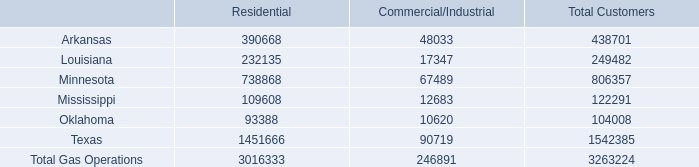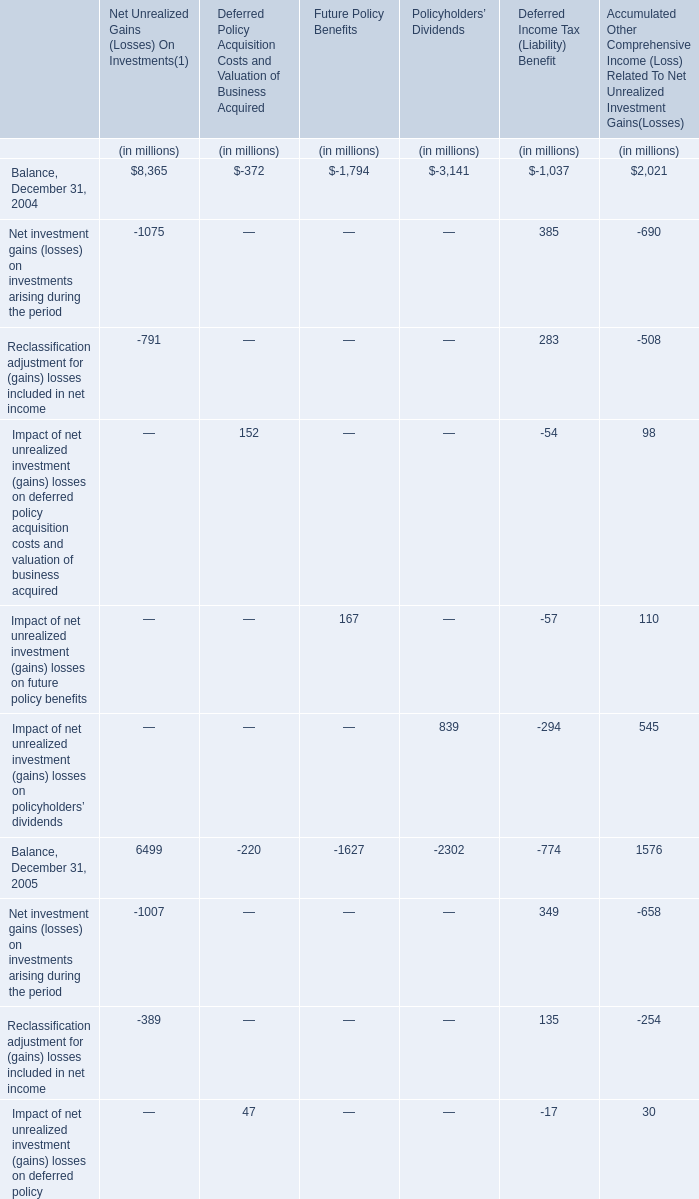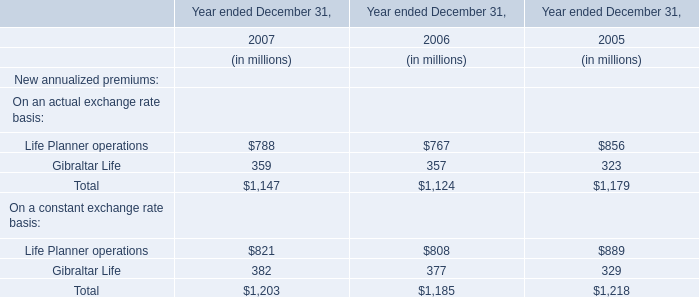In which section the sum of Balance, December 31, 2004 has the highest value? 
Answer: Net Unrealized Gains (Losses) On Investments(1). 